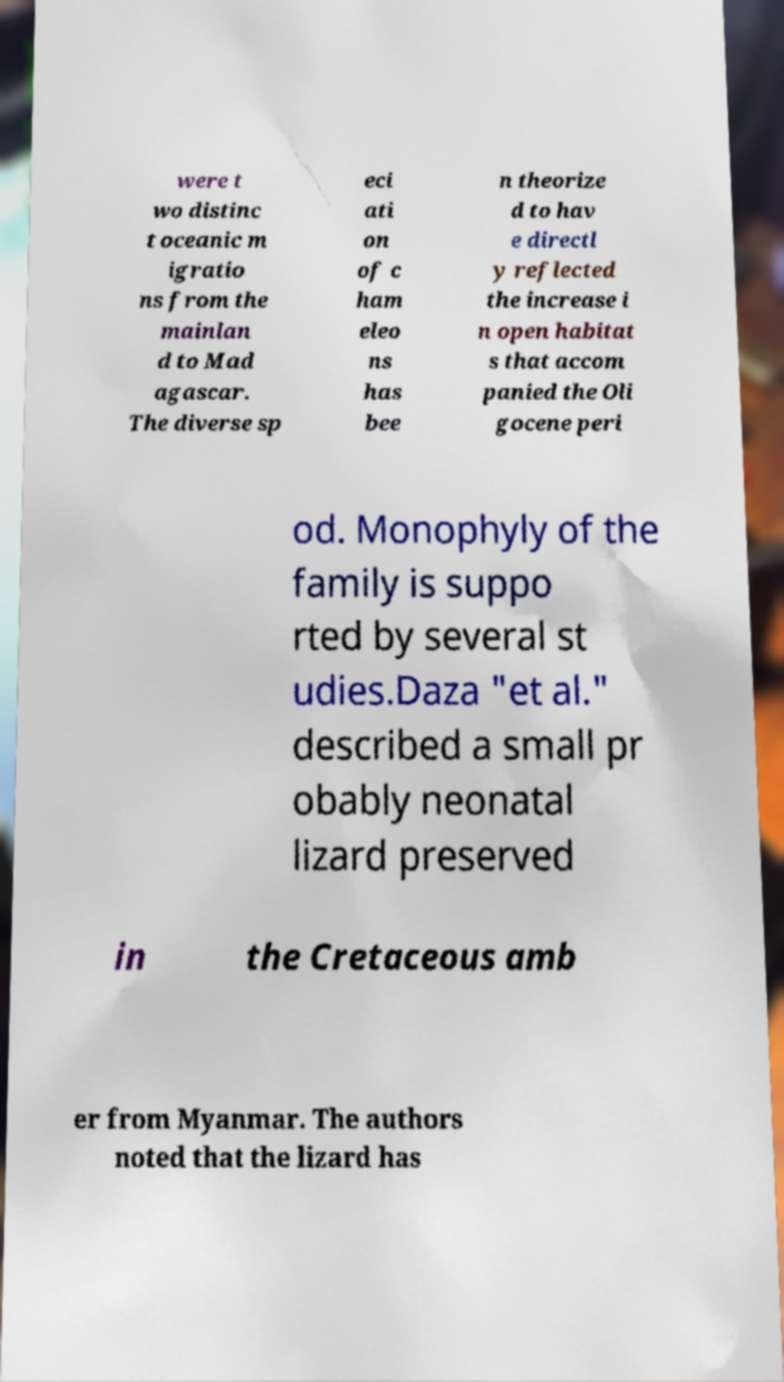Could you assist in decoding the text presented in this image and type it out clearly? were t wo distinc t oceanic m igratio ns from the mainlan d to Mad agascar. The diverse sp eci ati on of c ham eleo ns has bee n theorize d to hav e directl y reflected the increase i n open habitat s that accom panied the Oli gocene peri od. Monophyly of the family is suppo rted by several st udies.Daza "et al." described a small pr obably neonatal lizard preserved in the Cretaceous amb er from Myanmar. The authors noted that the lizard has 